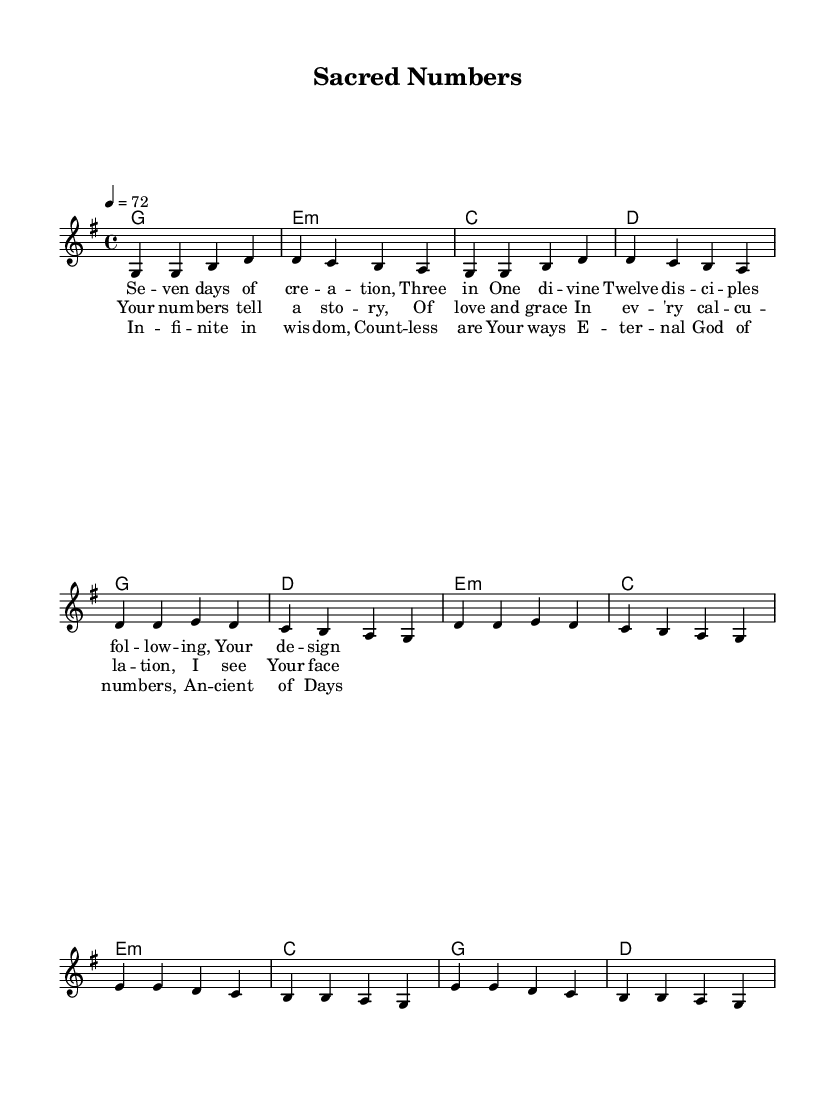What is the key signature of this music? The key signature shows one sharp, indicating all F notes are sharp throughout the piece.
Answer: G major What is the time signature of this music? The time signature, found at the beginning of the score, is four beats per measure, commonly represented as a fraction.
Answer: 4/4 What is the tempo marking indicated in this music? The tempo marking is notated at the beginning, stating the speed of the piece as 72 beats per minute.
Answer: 72 How many verses are present in this piece? By counting the sections labeled in the sheet music, there are distinct segments, indicating the number of verses present.
Answer: One What numerical symbolism is referenced in the lyrics of this song? The lyrics mention "Seven days of creation" and "Three in One," highlighting significant biblical numbers representing creation and the Trinity.
Answer: Seven and Three Which chord is used in the chorus section? Checking the harmonic progression in the chorus, we can find the chords listed in order, revealing the presence of a specific chord type used.
Answer: E minor What is the structure of the bridge in this song? Analyzing the structure shows that the bridge follows a specific pattern characterized by mentioning infinite wisdom and eternal traits, representing theological concepts in music.
Answer: Call and response 